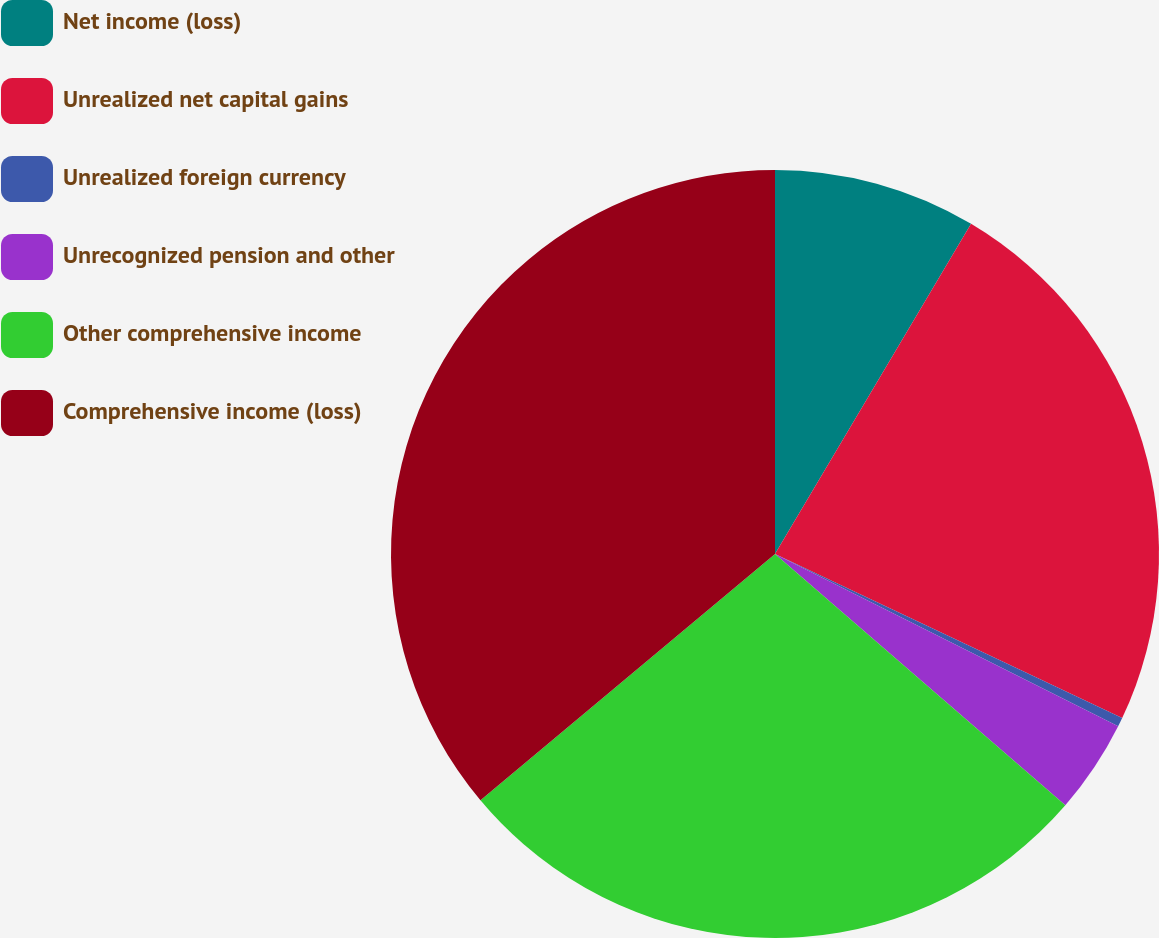Convert chart. <chart><loc_0><loc_0><loc_500><loc_500><pie_chart><fcel>Net income (loss)<fcel>Unrealized net capital gains<fcel>Unrealized foreign currency<fcel>Unrecognized pension and other<fcel>Other comprehensive income<fcel>Comprehensive income (loss)<nl><fcel>8.53%<fcel>23.5%<fcel>0.38%<fcel>3.95%<fcel>27.56%<fcel>36.09%<nl></chart> 